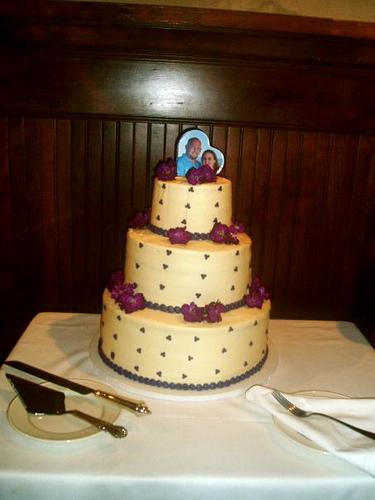What is scattered around the cake?
Keep it brief. Flowers. What type of event is this cake for?
Short answer required. Wedding. Where is the cake?
Short answer required. On table. What color is the knife handle?
Keep it brief. Gold. What color is the cake?
Concise answer only. Yellow. How many tiers does this cake have?
Short answer required. 3. How many people are in this photo?
Quick response, please. 0. 